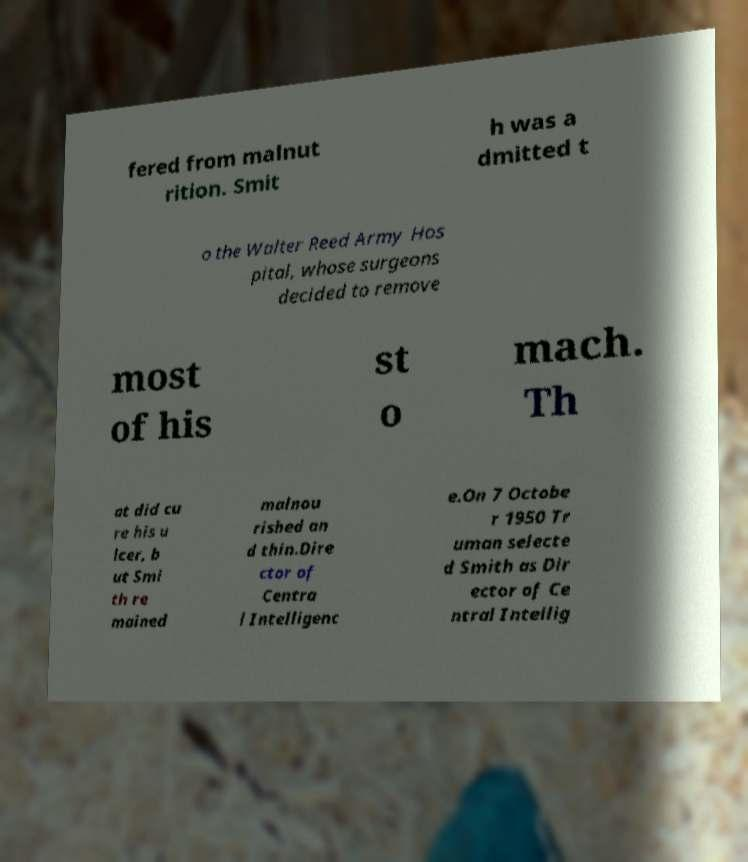There's text embedded in this image that I need extracted. Can you transcribe it verbatim? fered from malnut rition. Smit h was a dmitted t o the Walter Reed Army Hos pital, whose surgeons decided to remove most of his st o mach. Th at did cu re his u lcer, b ut Smi th re mained malnou rished an d thin.Dire ctor of Centra l Intelligenc e.On 7 Octobe r 1950 Tr uman selecte d Smith as Dir ector of Ce ntral Intellig 